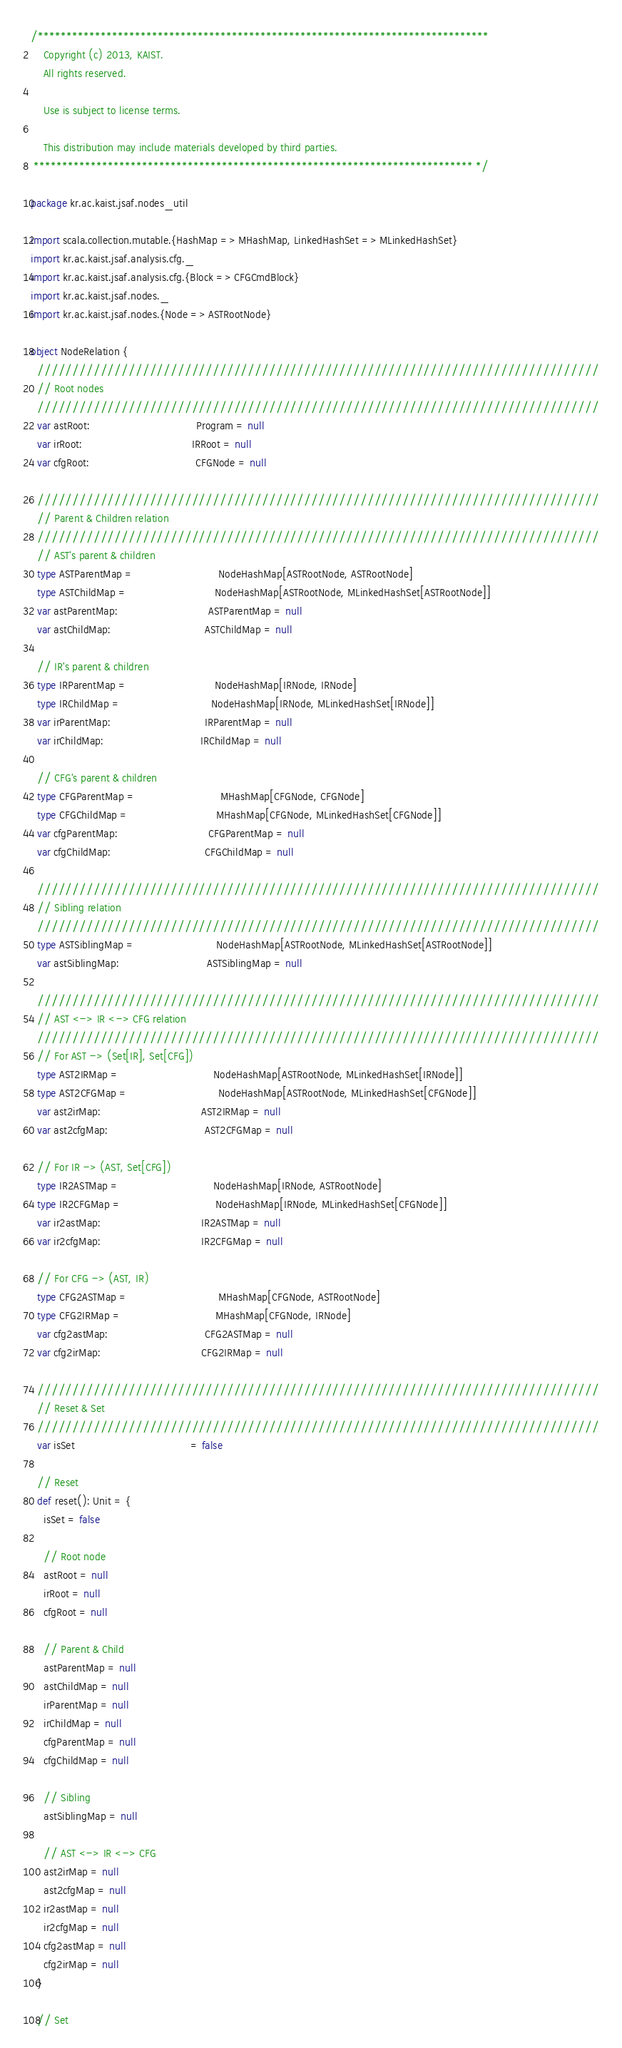Convert code to text. <code><loc_0><loc_0><loc_500><loc_500><_Scala_>/*******************************************************************************
    Copyright (c) 2013, KAIST.
    All rights reserved.

    Use is subject to license terms.

    This distribution may include materials developed by third parties.
 ***************************************************************************** */

package kr.ac.kaist.jsaf.nodes_util

import scala.collection.mutable.{HashMap => MHashMap, LinkedHashSet => MLinkedHashSet}
import kr.ac.kaist.jsaf.analysis.cfg._
import kr.ac.kaist.jsaf.analysis.cfg.{Block => CFGCmdBlock}
import kr.ac.kaist.jsaf.nodes._
import kr.ac.kaist.jsaf.nodes.{Node => ASTRootNode}

object NodeRelation {
  ////////////////////////////////////////////////////////////////////////////////
  // Root nodes
  ////////////////////////////////////////////////////////////////////////////////
  var astRoot:                                  Program = null
  var irRoot:                                   IRRoot = null
  var cfgRoot:                                  CFGNode = null

  ////////////////////////////////////////////////////////////////////////////////
  // Parent & Children relation
  ////////////////////////////////////////////////////////////////////////////////
  // AST's parent & children
  type ASTParentMap =                           NodeHashMap[ASTRootNode, ASTRootNode]
  type ASTChildMap =                            NodeHashMap[ASTRootNode, MLinkedHashSet[ASTRootNode]]
  var astParentMap:                             ASTParentMap = null
  var astChildMap:                              ASTChildMap = null

  // IR's parent & children
  type IRParentMap =                            NodeHashMap[IRNode, IRNode]
  type IRChildMap =                             NodeHashMap[IRNode, MLinkedHashSet[IRNode]]
  var irParentMap:                              IRParentMap = null
  var irChildMap:                               IRChildMap = null

  // CFG's parent & children
  type CFGParentMap =                           MHashMap[CFGNode, CFGNode]
  type CFGChildMap =                            MHashMap[CFGNode, MLinkedHashSet[CFGNode]]
  var cfgParentMap:                             CFGParentMap = null
  var cfgChildMap:                              CFGChildMap = null

  ////////////////////////////////////////////////////////////////////////////////
  // Sibling relation
  ////////////////////////////////////////////////////////////////////////////////
  type ASTSiblingMap =                          NodeHashMap[ASTRootNode, MLinkedHashSet[ASTRootNode]]
  var astSiblingMap:                            ASTSiblingMap = null

  ////////////////////////////////////////////////////////////////////////////////
  // AST <-> IR <-> CFG relation
  ////////////////////////////////////////////////////////////////////////////////
  // For AST -> (Set[IR], Set[CFG])
  type AST2IRMap =                              NodeHashMap[ASTRootNode, MLinkedHashSet[IRNode]]
  type AST2CFGMap =                             NodeHashMap[ASTRootNode, MLinkedHashSet[CFGNode]]
  var ast2irMap:                                AST2IRMap = null
  var ast2cfgMap:                               AST2CFGMap = null

  // For IR -> (AST, Set[CFG])
  type IR2ASTMap =                              NodeHashMap[IRNode, ASTRootNode]
  type IR2CFGMap =                              NodeHashMap[IRNode, MLinkedHashSet[CFGNode]]
  var ir2astMap:                                IR2ASTMap = null
  var ir2cfgMap:                                IR2CFGMap = null

  // For CFG -> (AST, IR)
  type CFG2ASTMap =                             MHashMap[CFGNode, ASTRootNode]
  type CFG2IRMap =                              MHashMap[CFGNode, IRNode]
  var cfg2astMap:                               CFG2ASTMap = null
  var cfg2irMap:                                CFG2IRMap = null

  ////////////////////////////////////////////////////////////////////////////////
  // Reset & Set
  ////////////////////////////////////////////////////////////////////////////////
  var isSet                                     = false

  // Reset
  def reset(): Unit = {
    isSet = false

    // Root node
    astRoot = null
    irRoot = null
    cfgRoot = null

    // Parent & Child
    astParentMap = null
    astChildMap = null
    irParentMap = null
    irChildMap = null
    cfgParentMap = null
    cfgChildMap = null

    // Sibling
    astSiblingMap = null

    // AST <-> IR <-> CFG
    ast2irMap = null
    ast2cfgMap = null
    ir2astMap = null
    ir2cfgMap = null
    cfg2astMap = null
    cfg2irMap = null
  }

  // Set</code> 